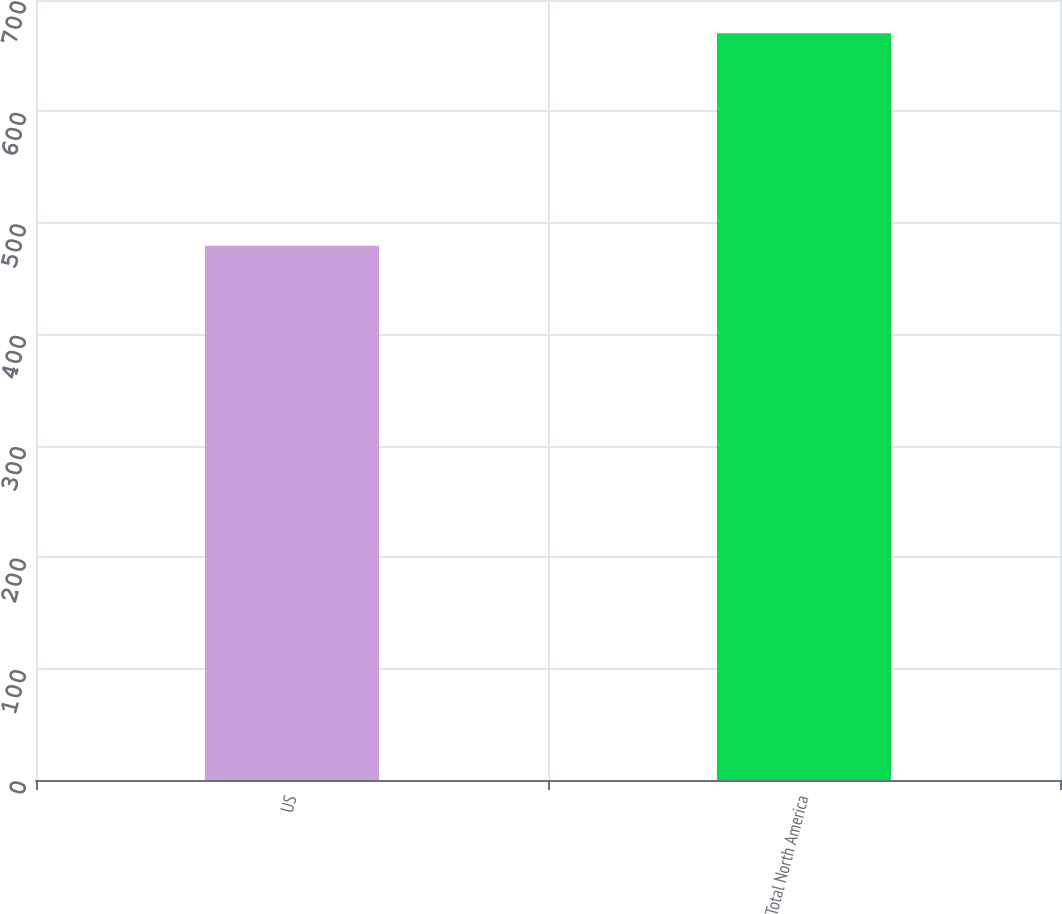Convert chart. <chart><loc_0><loc_0><loc_500><loc_500><bar_chart><fcel>US<fcel>Total North America<nl><fcel>479.4<fcel>670.2<nl></chart> 